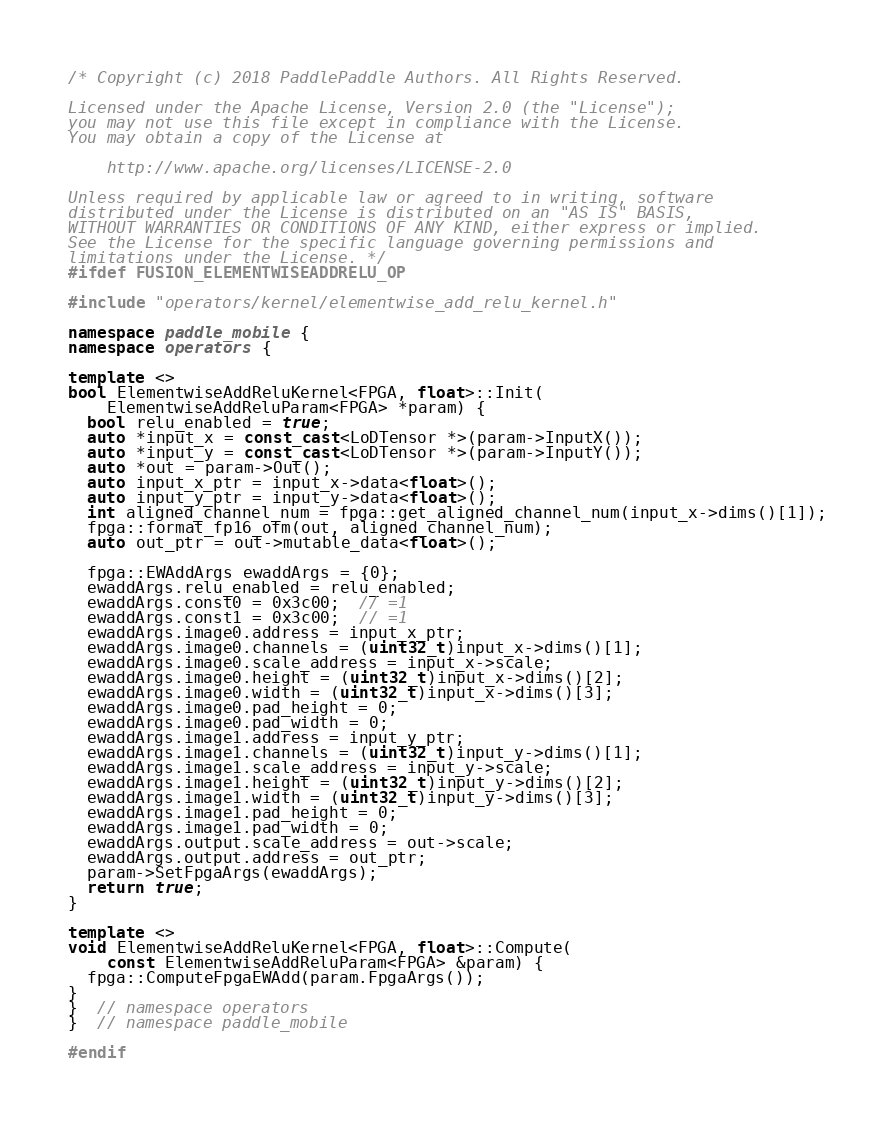<code> <loc_0><loc_0><loc_500><loc_500><_C++_>/* Copyright (c) 2018 PaddlePaddle Authors. All Rights Reserved.

Licensed under the Apache License, Version 2.0 (the "License");
you may not use this file except in compliance with the License.
You may obtain a copy of the License at

    http://www.apache.org/licenses/LICENSE-2.0

Unless required by applicable law or agreed to in writing, software
distributed under the License is distributed on an "AS IS" BASIS,
WITHOUT WARRANTIES OR CONDITIONS OF ANY KIND, either express or implied.
See the License for the specific language governing permissions and
limitations under the License. */
#ifdef FUSION_ELEMENTWISEADDRELU_OP

#include "operators/kernel/elementwise_add_relu_kernel.h"

namespace paddle_mobile {
namespace operators {

template <>
bool ElementwiseAddReluKernel<FPGA, float>::Init(
    ElementwiseAddReluParam<FPGA> *param) {
  bool relu_enabled = true;
  auto *input_x = const_cast<LoDTensor *>(param->InputX());
  auto *input_y = const_cast<LoDTensor *>(param->InputY());
  auto *out = param->Out();
  auto input_x_ptr = input_x->data<float>();
  auto input_y_ptr = input_y->data<float>();
  int aligned_channel_num = fpga::get_aligned_channel_num(input_x->dims()[1]);
  fpga::format_fp16_ofm(out, aligned_channel_num);
  auto out_ptr = out->mutable_data<float>();

  fpga::EWAddArgs ewaddArgs = {0};
  ewaddArgs.relu_enabled = relu_enabled;
  ewaddArgs.const0 = 0x3c00;  // =1
  ewaddArgs.const1 = 0x3c00;  // =1
  ewaddArgs.image0.address = input_x_ptr;
  ewaddArgs.image0.channels = (uint32_t)input_x->dims()[1];
  ewaddArgs.image0.scale_address = input_x->scale;
  ewaddArgs.image0.height = (uint32_t)input_x->dims()[2];
  ewaddArgs.image0.width = (uint32_t)input_x->dims()[3];
  ewaddArgs.image0.pad_height = 0;
  ewaddArgs.image0.pad_width = 0;
  ewaddArgs.image1.address = input_y_ptr;
  ewaddArgs.image1.channels = (uint32_t)input_y->dims()[1];
  ewaddArgs.image1.scale_address = input_y->scale;
  ewaddArgs.image1.height = (uint32_t)input_y->dims()[2];
  ewaddArgs.image1.width = (uint32_t)input_y->dims()[3];
  ewaddArgs.image1.pad_height = 0;
  ewaddArgs.image1.pad_width = 0;
  ewaddArgs.output.scale_address = out->scale;
  ewaddArgs.output.address = out_ptr;
  param->SetFpgaArgs(ewaddArgs);
  return true;
}

template <>
void ElementwiseAddReluKernel<FPGA, float>::Compute(
    const ElementwiseAddReluParam<FPGA> &param) {
  fpga::ComputeFpgaEWAdd(param.FpgaArgs());
}
}  // namespace operators
}  // namespace paddle_mobile

#endif
</code> 